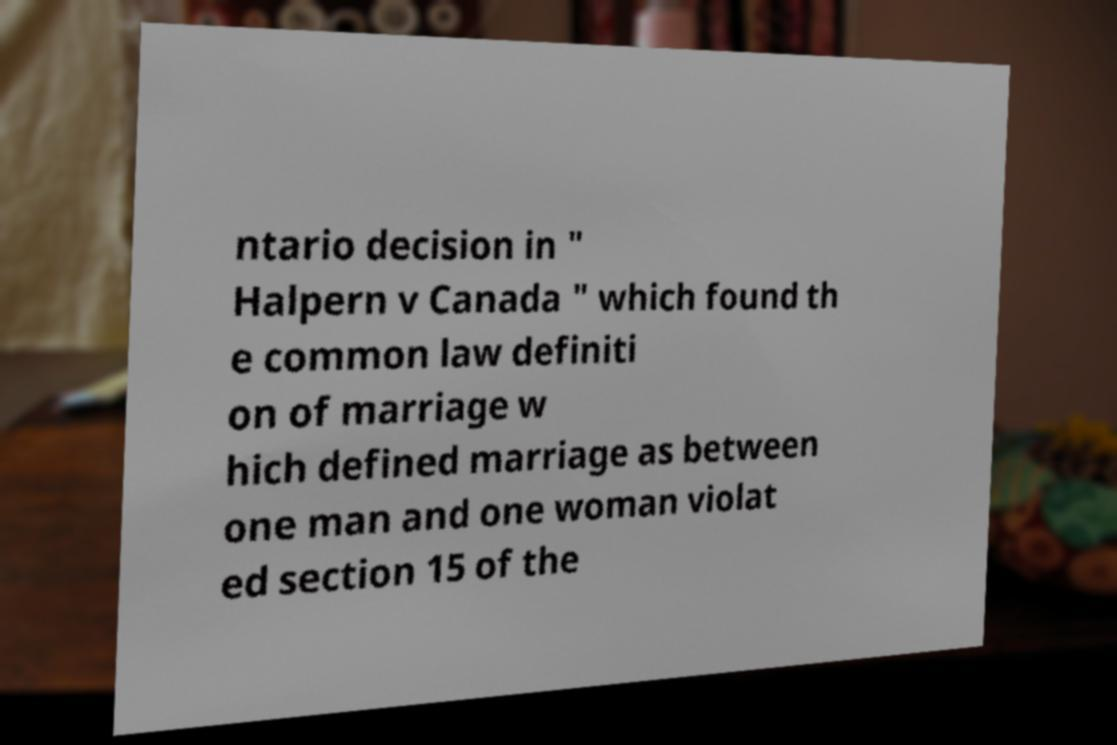Could you assist in decoding the text presented in this image and type it out clearly? ntario decision in " Halpern v Canada " which found th e common law definiti on of marriage w hich defined marriage as between one man and one woman violat ed section 15 of the 